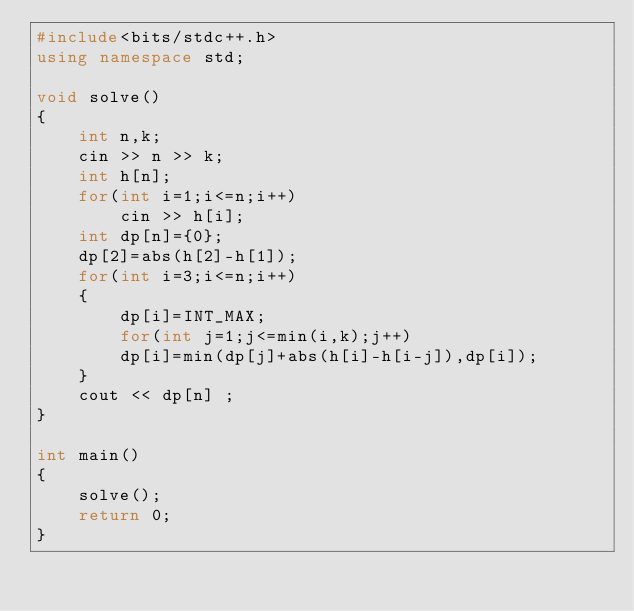Convert code to text. <code><loc_0><loc_0><loc_500><loc_500><_C++_>#include<bits/stdc++.h>
using namespace std;

void solve()
{
    int n,k;
    cin >> n >> k;
    int h[n];
    for(int i=1;i<=n;i++)
        cin >> h[i];
    int dp[n]={0};
    dp[2]=abs(h[2]-h[1]);
    for(int i=3;i<=n;i++)
    {
        dp[i]=INT_MAX;
        for(int j=1;j<=min(i,k);j++)
        dp[i]=min(dp[j]+abs(h[i]-h[i-j]),dp[i]);
    }
    cout << dp[n] ;
}

int main()
{
    solve();
    return 0;
}</code> 